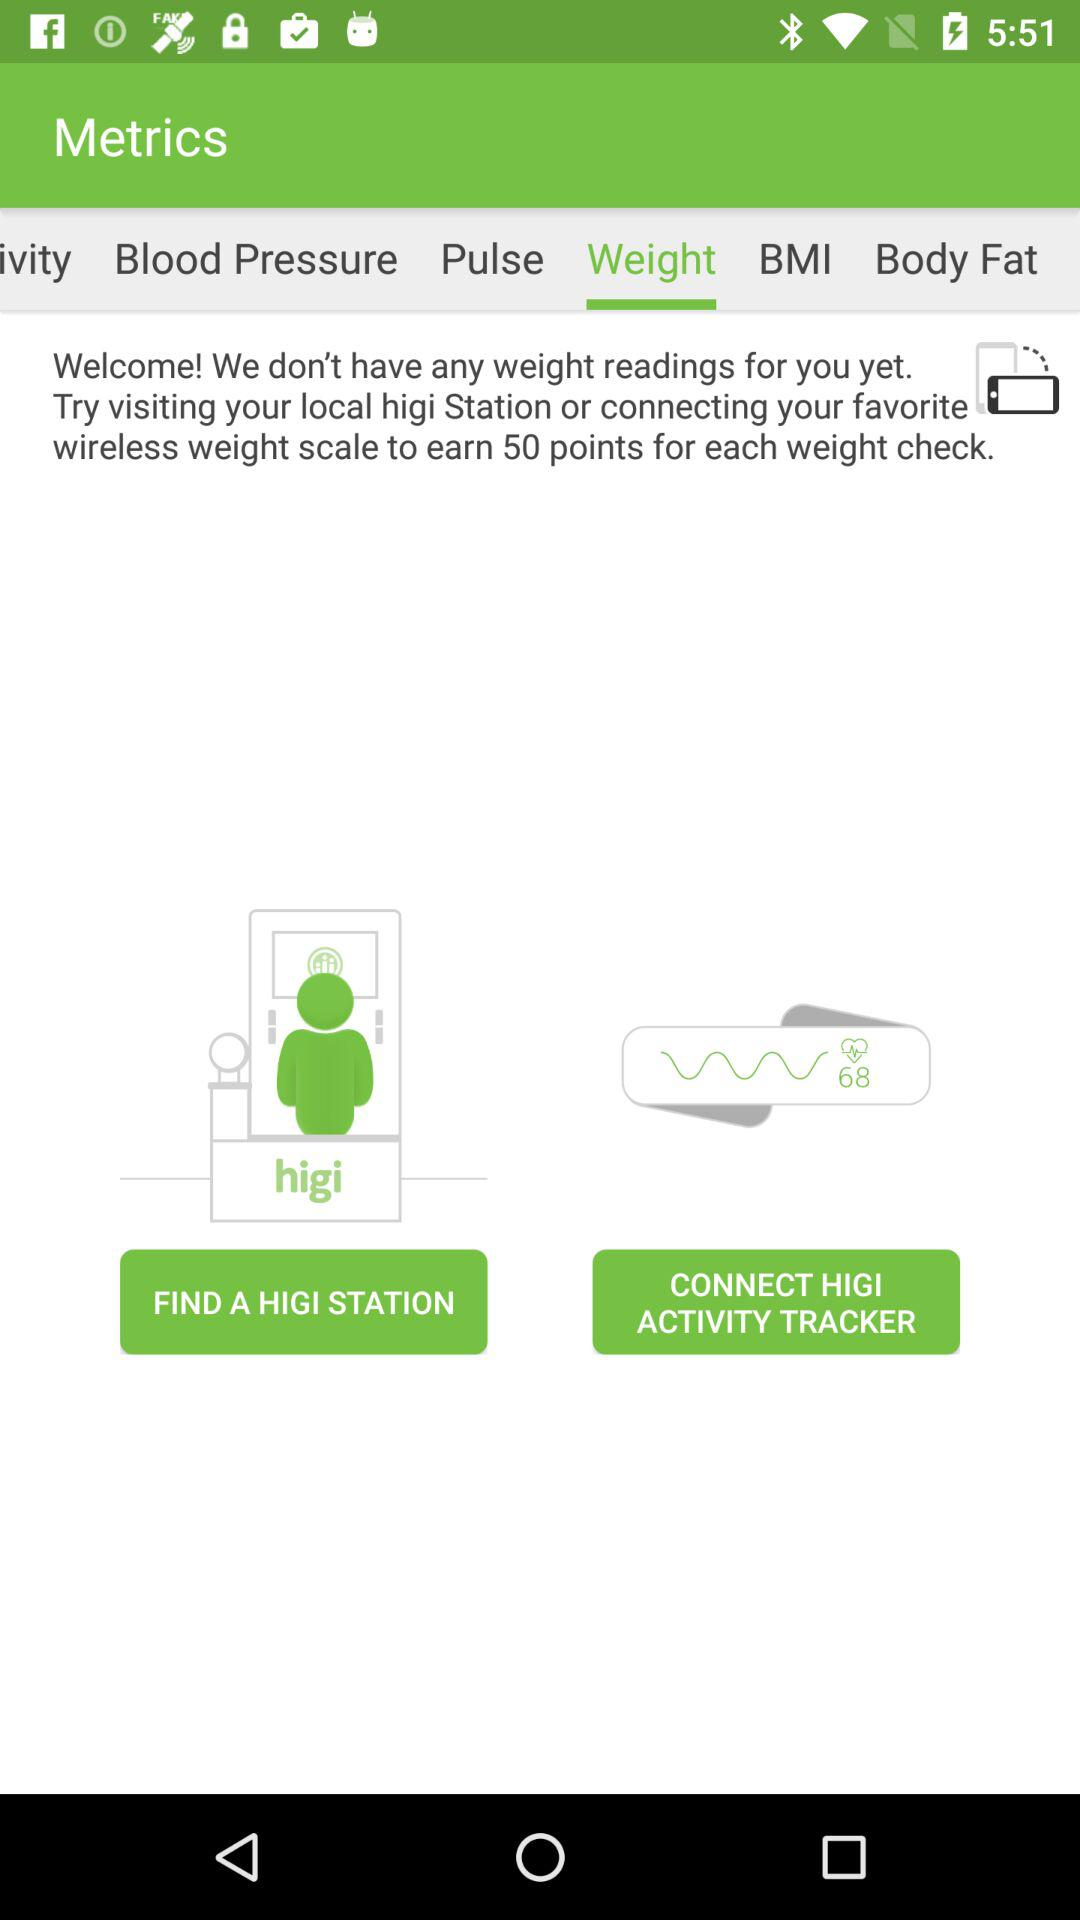What is the application name? The application name is "Metrics". 